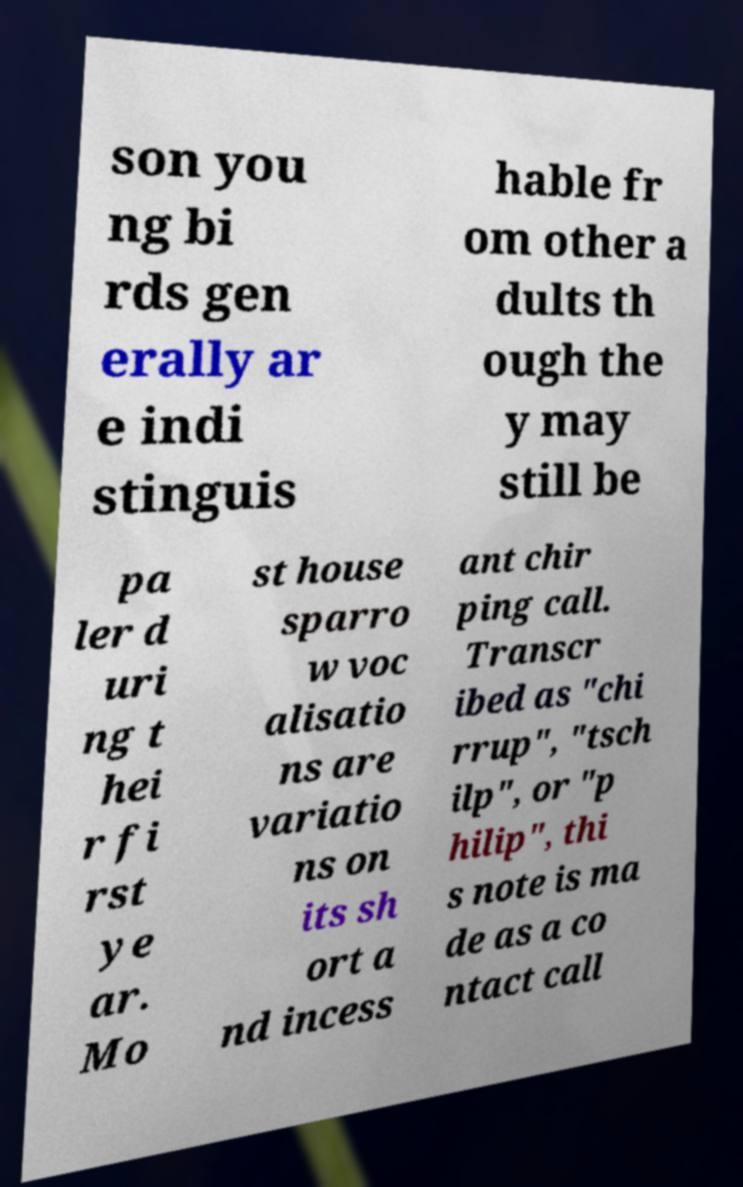Please read and relay the text visible in this image. What does it say? son you ng bi rds gen erally ar e indi stinguis hable fr om other a dults th ough the y may still be pa ler d uri ng t hei r fi rst ye ar. Mo st house sparro w voc alisatio ns are variatio ns on its sh ort a nd incess ant chir ping call. Transcr ibed as "chi rrup", "tsch ilp", or "p hilip", thi s note is ma de as a co ntact call 